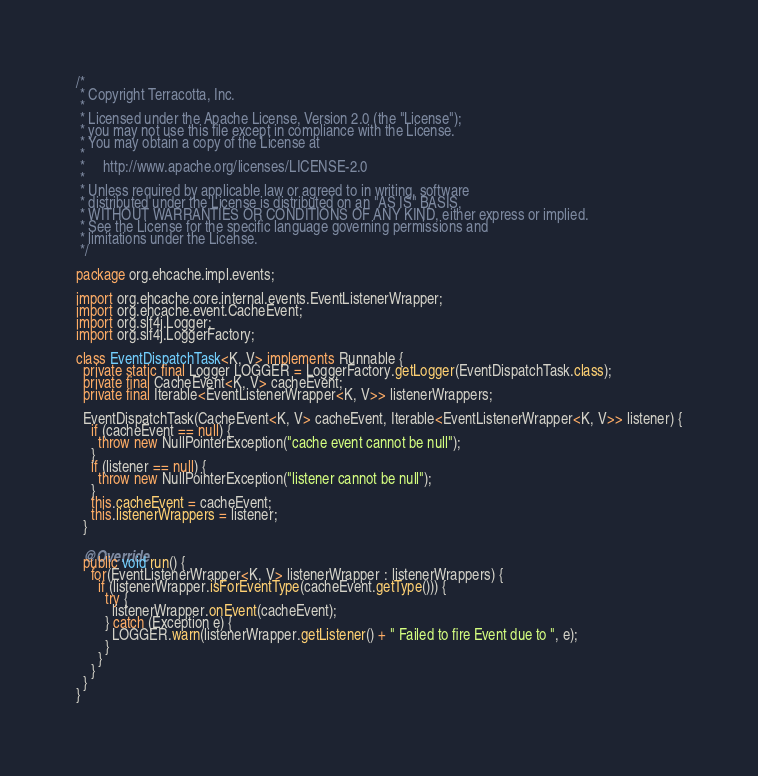Convert code to text. <code><loc_0><loc_0><loc_500><loc_500><_Java_>/*
 * Copyright Terracotta, Inc.
 *
 * Licensed under the Apache License, Version 2.0 (the "License");
 * you may not use this file except in compliance with the License.
 * You may obtain a copy of the License at
 *
 *     http://www.apache.org/licenses/LICENSE-2.0
 *
 * Unless required by applicable law or agreed to in writing, software
 * distributed under the License is distributed on an "AS IS" BASIS,
 * WITHOUT WARRANTIES OR CONDITIONS OF ANY KIND, either express or implied.
 * See the License for the specific language governing permissions and
 * limitations under the License.
 */

package org.ehcache.impl.events;

import org.ehcache.core.internal.events.EventListenerWrapper;
import org.ehcache.event.CacheEvent;
import org.slf4j.Logger;
import org.slf4j.LoggerFactory;

class EventDispatchTask<K, V> implements Runnable {
  private static final Logger LOGGER = LoggerFactory.getLogger(EventDispatchTask.class);
  private final CacheEvent<K, V> cacheEvent;
  private final Iterable<EventListenerWrapper<K, V>> listenerWrappers;

  EventDispatchTask(CacheEvent<K, V> cacheEvent, Iterable<EventListenerWrapper<K, V>> listener) {
    if (cacheEvent == null) {
      throw new NullPointerException("cache event cannot be null");
    }
    if (listener == null) {
      throw new NullPointerException("listener cannot be null");
    }
    this.cacheEvent = cacheEvent;
    this.listenerWrappers = listener;
  }

  @Override
  public void run() {
    for(EventListenerWrapper<K, V> listenerWrapper : listenerWrappers) {
      if (listenerWrapper.isForEventType(cacheEvent.getType())) {
        try {
          listenerWrapper.onEvent(cacheEvent);
        } catch (Exception e) {
          LOGGER.warn(listenerWrapper.getListener() + " Failed to fire Event due to ", e);
        }
      }
    }
  }
}
</code> 